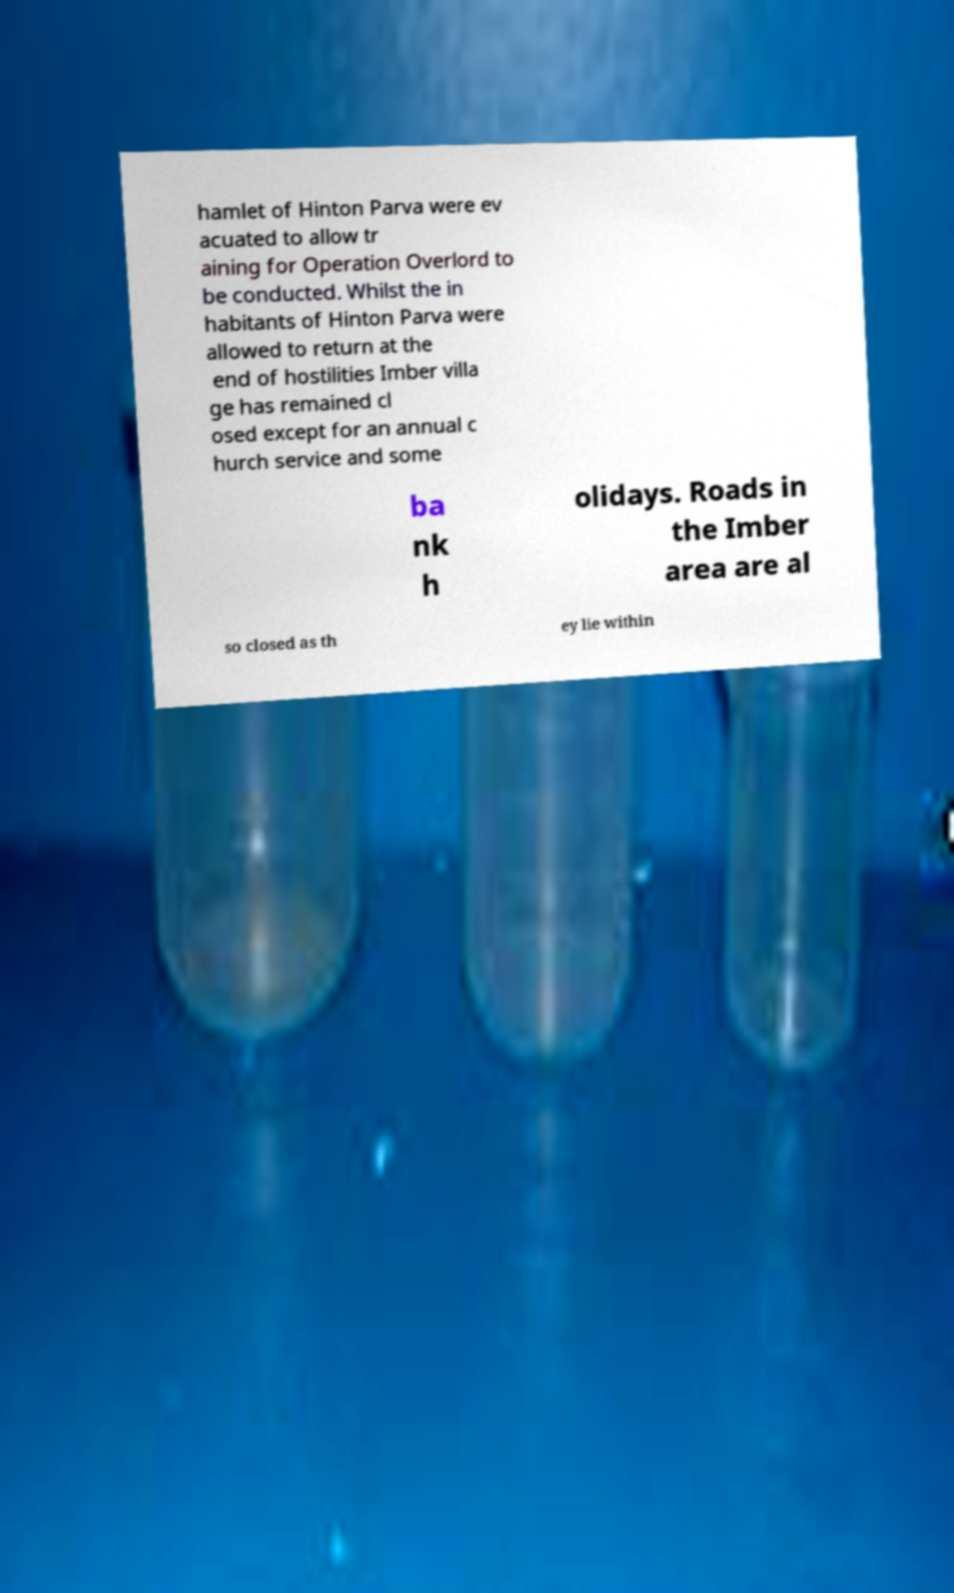Can you read and provide the text displayed in the image?This photo seems to have some interesting text. Can you extract and type it out for me? hamlet of Hinton Parva were ev acuated to allow tr aining for Operation Overlord to be conducted. Whilst the in habitants of Hinton Parva were allowed to return at the end of hostilities Imber villa ge has remained cl osed except for an annual c hurch service and some ba nk h olidays. Roads in the Imber area are al so closed as th ey lie within 